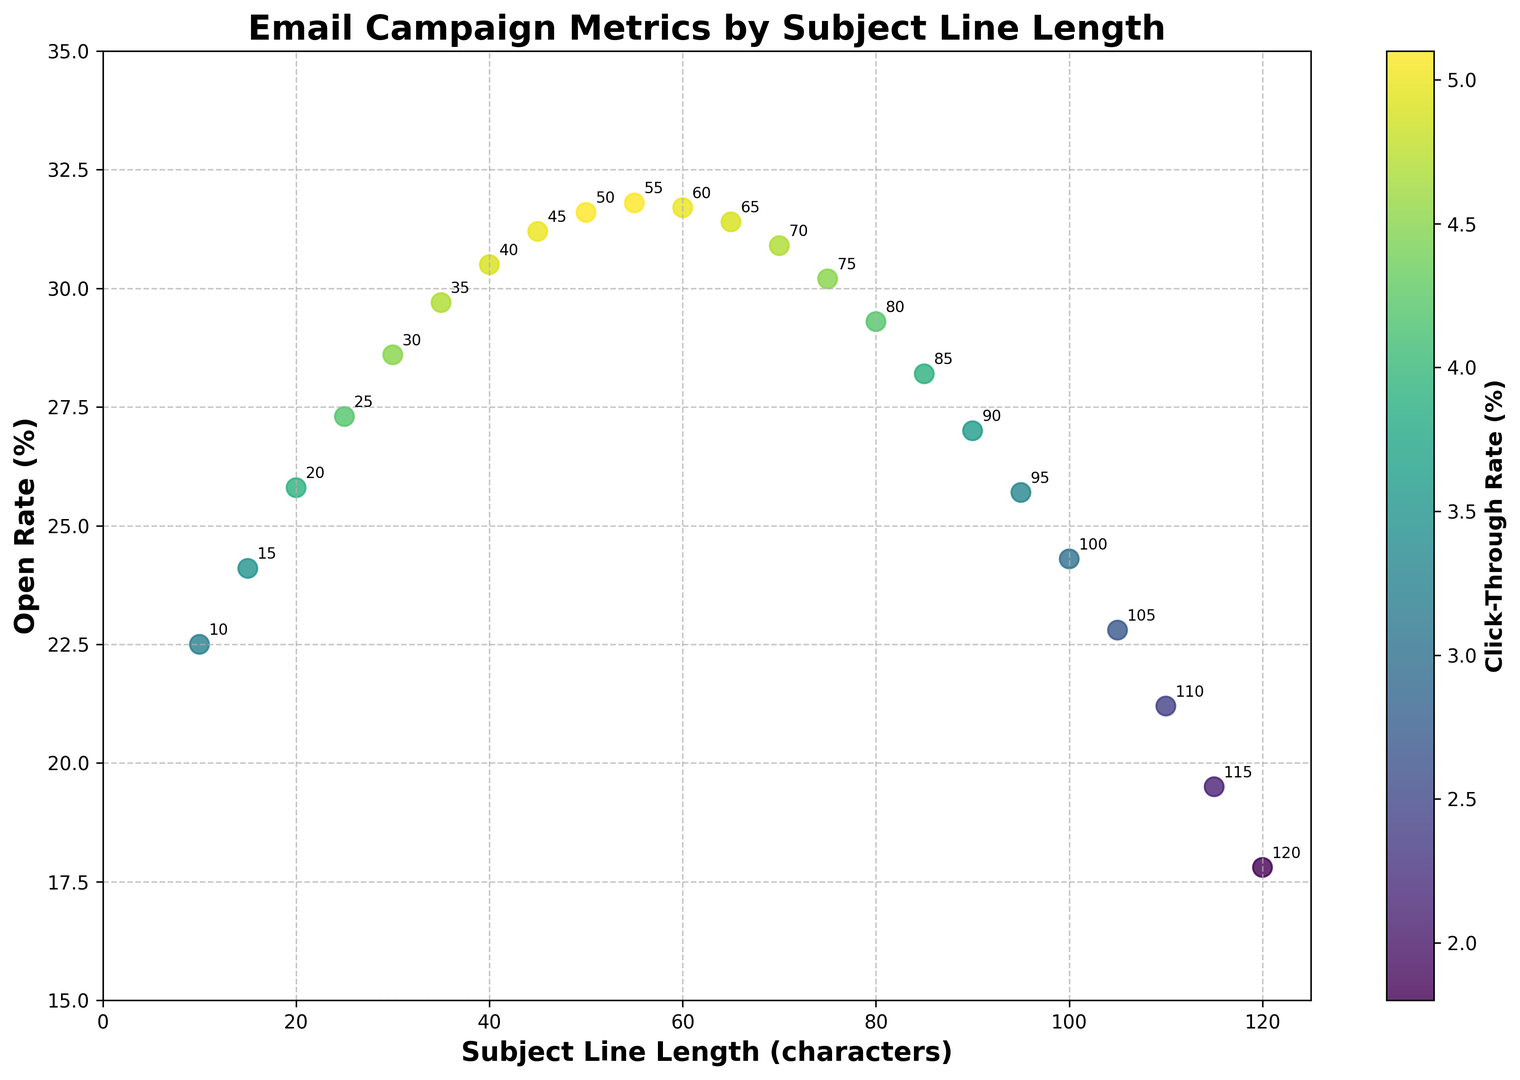What is the range of open rates visible in the plot? The plot indicates the minimum open rate is 17.8% and the maximum is 31.8%, which can be observed from the y-axis values.
Answer: 17.8% to 31.8% Which subject line length corresponds to the highest click-through rate? By examining the color bar and the scatter points, the darkest point (highest click-through rate) corresponds to a subject line length of 55 characters.
Answer: 55 characters Is the open rate increasing or decreasing for subject line lengths greater than 70 characters? Observing the trend in the scatter plot shows that the open rate decreases for subject line lengths greater than 70 characters.
Answer: Decreasing Compare the open rates of subject line lengths 20 and 65 characters. Which one is higher? The scatter plot shows that the open rate for 20 characters is 25.8%, and for 65 characters, it is 31.4%. Therefore, the open rate for 65 characters is higher.
Answer: 65 characters What color on the scatter plot represents the highest click-through rate? The color bar indicates the highest click-through rate is marked by the darkest color, which is a deep shade present in the viridis color map.
Answer: Darkest shade What is the difference between the open rates of the shortest and the longest subject line lengths? The open rate for the shortest subject line length (10 characters) is 22.5%, and for the longest (120 characters) is 17.8%. The difference is 22.5% - 17.8% = 4.7%.
Answer: 4.7% Identify the subject line length with an open rate around 30% but a click-through rate less than 5%. Referring to the plot, a subject line length of 70 characters has a 30.9% open rate and just below 5% click-through rate.
Answer: 70 characters Which subject line length has the steepest decline in open rate immediately after its peak? The peak open rate occurs at 55 characters (31.8%). The sharp decline is observed after 55 characters, particularly from 60 characters (31.7%) to 70 characters (30.9%).
Answer: 55 to 70 characters Are there any subject line lengths with open rates consistently above 25%? From the plot, subject lines with lengths ranging from 20 to 60 characters all have open rates that are consistently above 25%.
Answer: 20 to 60 characters 